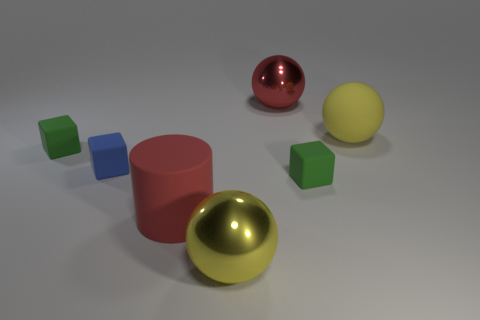Subtract 1 cubes. How many cubes are left? 2 Add 1 big yellow rubber things. How many objects exist? 8 Subtract all blocks. How many objects are left? 4 Subtract 0 yellow cylinders. How many objects are left? 7 Subtract all green rubber objects. Subtract all large yellow shiny objects. How many objects are left? 4 Add 4 green matte objects. How many green matte objects are left? 6 Add 2 red metallic blocks. How many red metallic blocks exist? 2 